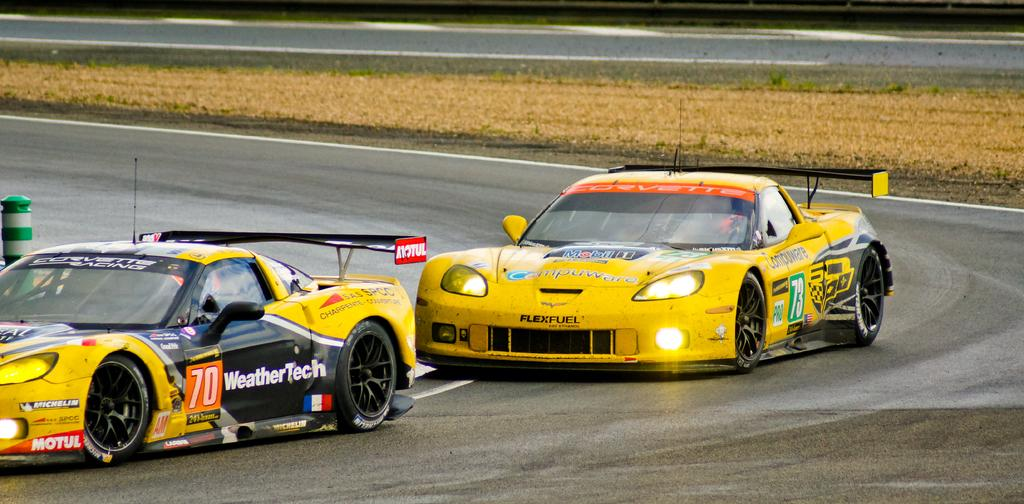How many cars can be seen in the image? There are two colorful cars in the image. Where are the cars located? The cars are on the road in the image. What type of vegetation is visible in the image? There is dry grass visible in the image. What is the color and design of the pole in the image? The pole has green and ash colors in the image. What type of meat can be seen hanging from the pole in the image? There is no meat hanging from the pole in the image; it has green and ash colors. Are there any clouds visible in the image? The provided facts do not mention clouds, so we cannot determine if any are visible in the image. 